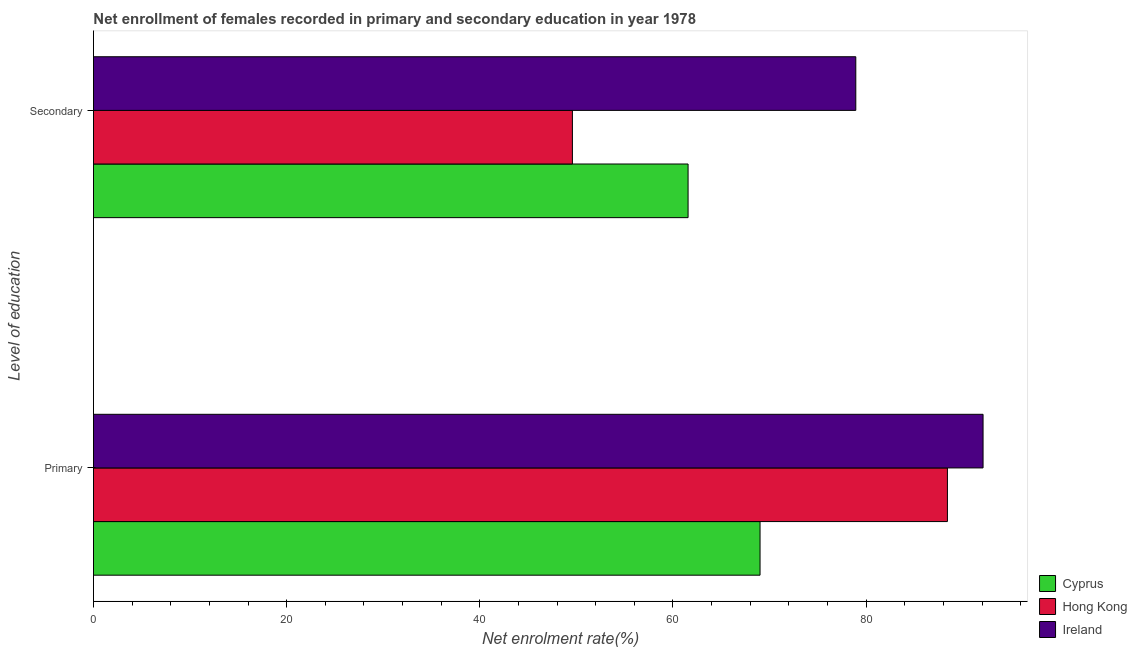What is the label of the 2nd group of bars from the top?
Provide a succinct answer. Primary. What is the enrollment rate in secondary education in Cyprus?
Your answer should be compact. 61.57. Across all countries, what is the maximum enrollment rate in primary education?
Offer a very short reply. 92.11. Across all countries, what is the minimum enrollment rate in primary education?
Your answer should be compact. 69.02. In which country was the enrollment rate in secondary education maximum?
Provide a succinct answer. Ireland. In which country was the enrollment rate in secondary education minimum?
Provide a short and direct response. Hong Kong. What is the total enrollment rate in primary education in the graph?
Offer a terse response. 249.55. What is the difference between the enrollment rate in primary education in Cyprus and that in Hong Kong?
Make the answer very short. -19.4. What is the difference between the enrollment rate in secondary education in Ireland and the enrollment rate in primary education in Hong Kong?
Offer a terse response. -9.49. What is the average enrollment rate in primary education per country?
Ensure brevity in your answer.  83.18. What is the difference between the enrollment rate in secondary education and enrollment rate in primary education in Hong Kong?
Your answer should be compact. -38.83. What is the ratio of the enrollment rate in secondary education in Cyprus to that in Ireland?
Your answer should be very brief. 0.78. In how many countries, is the enrollment rate in primary education greater than the average enrollment rate in primary education taken over all countries?
Offer a very short reply. 2. What does the 3rd bar from the top in Secondary represents?
Make the answer very short. Cyprus. What does the 2nd bar from the bottom in Secondary represents?
Ensure brevity in your answer.  Hong Kong. How many bars are there?
Provide a succinct answer. 6. Are the values on the major ticks of X-axis written in scientific E-notation?
Give a very brief answer. No. Does the graph contain grids?
Your response must be concise. No. Where does the legend appear in the graph?
Provide a succinct answer. Bottom right. How many legend labels are there?
Provide a short and direct response. 3. How are the legend labels stacked?
Your response must be concise. Vertical. What is the title of the graph?
Ensure brevity in your answer.  Net enrollment of females recorded in primary and secondary education in year 1978. What is the label or title of the X-axis?
Your answer should be very brief. Net enrolment rate(%). What is the label or title of the Y-axis?
Give a very brief answer. Level of education. What is the Net enrolment rate(%) of Cyprus in Primary?
Your answer should be very brief. 69.02. What is the Net enrolment rate(%) of Hong Kong in Primary?
Provide a succinct answer. 88.42. What is the Net enrolment rate(%) in Ireland in Primary?
Your answer should be compact. 92.11. What is the Net enrolment rate(%) in Cyprus in Secondary?
Give a very brief answer. 61.57. What is the Net enrolment rate(%) in Hong Kong in Secondary?
Your answer should be very brief. 49.59. What is the Net enrolment rate(%) in Ireland in Secondary?
Offer a very short reply. 78.93. Across all Level of education, what is the maximum Net enrolment rate(%) in Cyprus?
Provide a succinct answer. 69.02. Across all Level of education, what is the maximum Net enrolment rate(%) of Hong Kong?
Give a very brief answer. 88.42. Across all Level of education, what is the maximum Net enrolment rate(%) of Ireland?
Make the answer very short. 92.11. Across all Level of education, what is the minimum Net enrolment rate(%) of Cyprus?
Make the answer very short. 61.57. Across all Level of education, what is the minimum Net enrolment rate(%) in Hong Kong?
Ensure brevity in your answer.  49.59. Across all Level of education, what is the minimum Net enrolment rate(%) of Ireland?
Give a very brief answer. 78.93. What is the total Net enrolment rate(%) of Cyprus in the graph?
Ensure brevity in your answer.  130.59. What is the total Net enrolment rate(%) of Hong Kong in the graph?
Offer a terse response. 138.01. What is the total Net enrolment rate(%) of Ireland in the graph?
Provide a short and direct response. 171.04. What is the difference between the Net enrolment rate(%) in Cyprus in Primary and that in Secondary?
Provide a short and direct response. 7.45. What is the difference between the Net enrolment rate(%) in Hong Kong in Primary and that in Secondary?
Offer a very short reply. 38.83. What is the difference between the Net enrolment rate(%) in Ireland in Primary and that in Secondary?
Your answer should be compact. 13.18. What is the difference between the Net enrolment rate(%) in Cyprus in Primary and the Net enrolment rate(%) in Hong Kong in Secondary?
Make the answer very short. 19.43. What is the difference between the Net enrolment rate(%) of Cyprus in Primary and the Net enrolment rate(%) of Ireland in Secondary?
Your answer should be very brief. -9.91. What is the difference between the Net enrolment rate(%) of Hong Kong in Primary and the Net enrolment rate(%) of Ireland in Secondary?
Provide a succinct answer. 9.49. What is the average Net enrolment rate(%) of Cyprus per Level of education?
Your answer should be very brief. 65.29. What is the average Net enrolment rate(%) of Hong Kong per Level of education?
Your response must be concise. 69. What is the average Net enrolment rate(%) in Ireland per Level of education?
Keep it short and to the point. 85.52. What is the difference between the Net enrolment rate(%) of Cyprus and Net enrolment rate(%) of Hong Kong in Primary?
Offer a very short reply. -19.4. What is the difference between the Net enrolment rate(%) of Cyprus and Net enrolment rate(%) of Ireland in Primary?
Provide a succinct answer. -23.09. What is the difference between the Net enrolment rate(%) in Hong Kong and Net enrolment rate(%) in Ireland in Primary?
Your response must be concise. -3.69. What is the difference between the Net enrolment rate(%) of Cyprus and Net enrolment rate(%) of Hong Kong in Secondary?
Provide a short and direct response. 11.98. What is the difference between the Net enrolment rate(%) in Cyprus and Net enrolment rate(%) in Ireland in Secondary?
Offer a very short reply. -17.37. What is the difference between the Net enrolment rate(%) in Hong Kong and Net enrolment rate(%) in Ireland in Secondary?
Your answer should be very brief. -29.34. What is the ratio of the Net enrolment rate(%) of Cyprus in Primary to that in Secondary?
Offer a very short reply. 1.12. What is the ratio of the Net enrolment rate(%) of Hong Kong in Primary to that in Secondary?
Make the answer very short. 1.78. What is the ratio of the Net enrolment rate(%) in Ireland in Primary to that in Secondary?
Make the answer very short. 1.17. What is the difference between the highest and the second highest Net enrolment rate(%) of Cyprus?
Your answer should be compact. 7.45. What is the difference between the highest and the second highest Net enrolment rate(%) in Hong Kong?
Your answer should be compact. 38.83. What is the difference between the highest and the second highest Net enrolment rate(%) of Ireland?
Your answer should be compact. 13.18. What is the difference between the highest and the lowest Net enrolment rate(%) in Cyprus?
Offer a terse response. 7.45. What is the difference between the highest and the lowest Net enrolment rate(%) in Hong Kong?
Your answer should be very brief. 38.83. What is the difference between the highest and the lowest Net enrolment rate(%) of Ireland?
Your answer should be very brief. 13.18. 